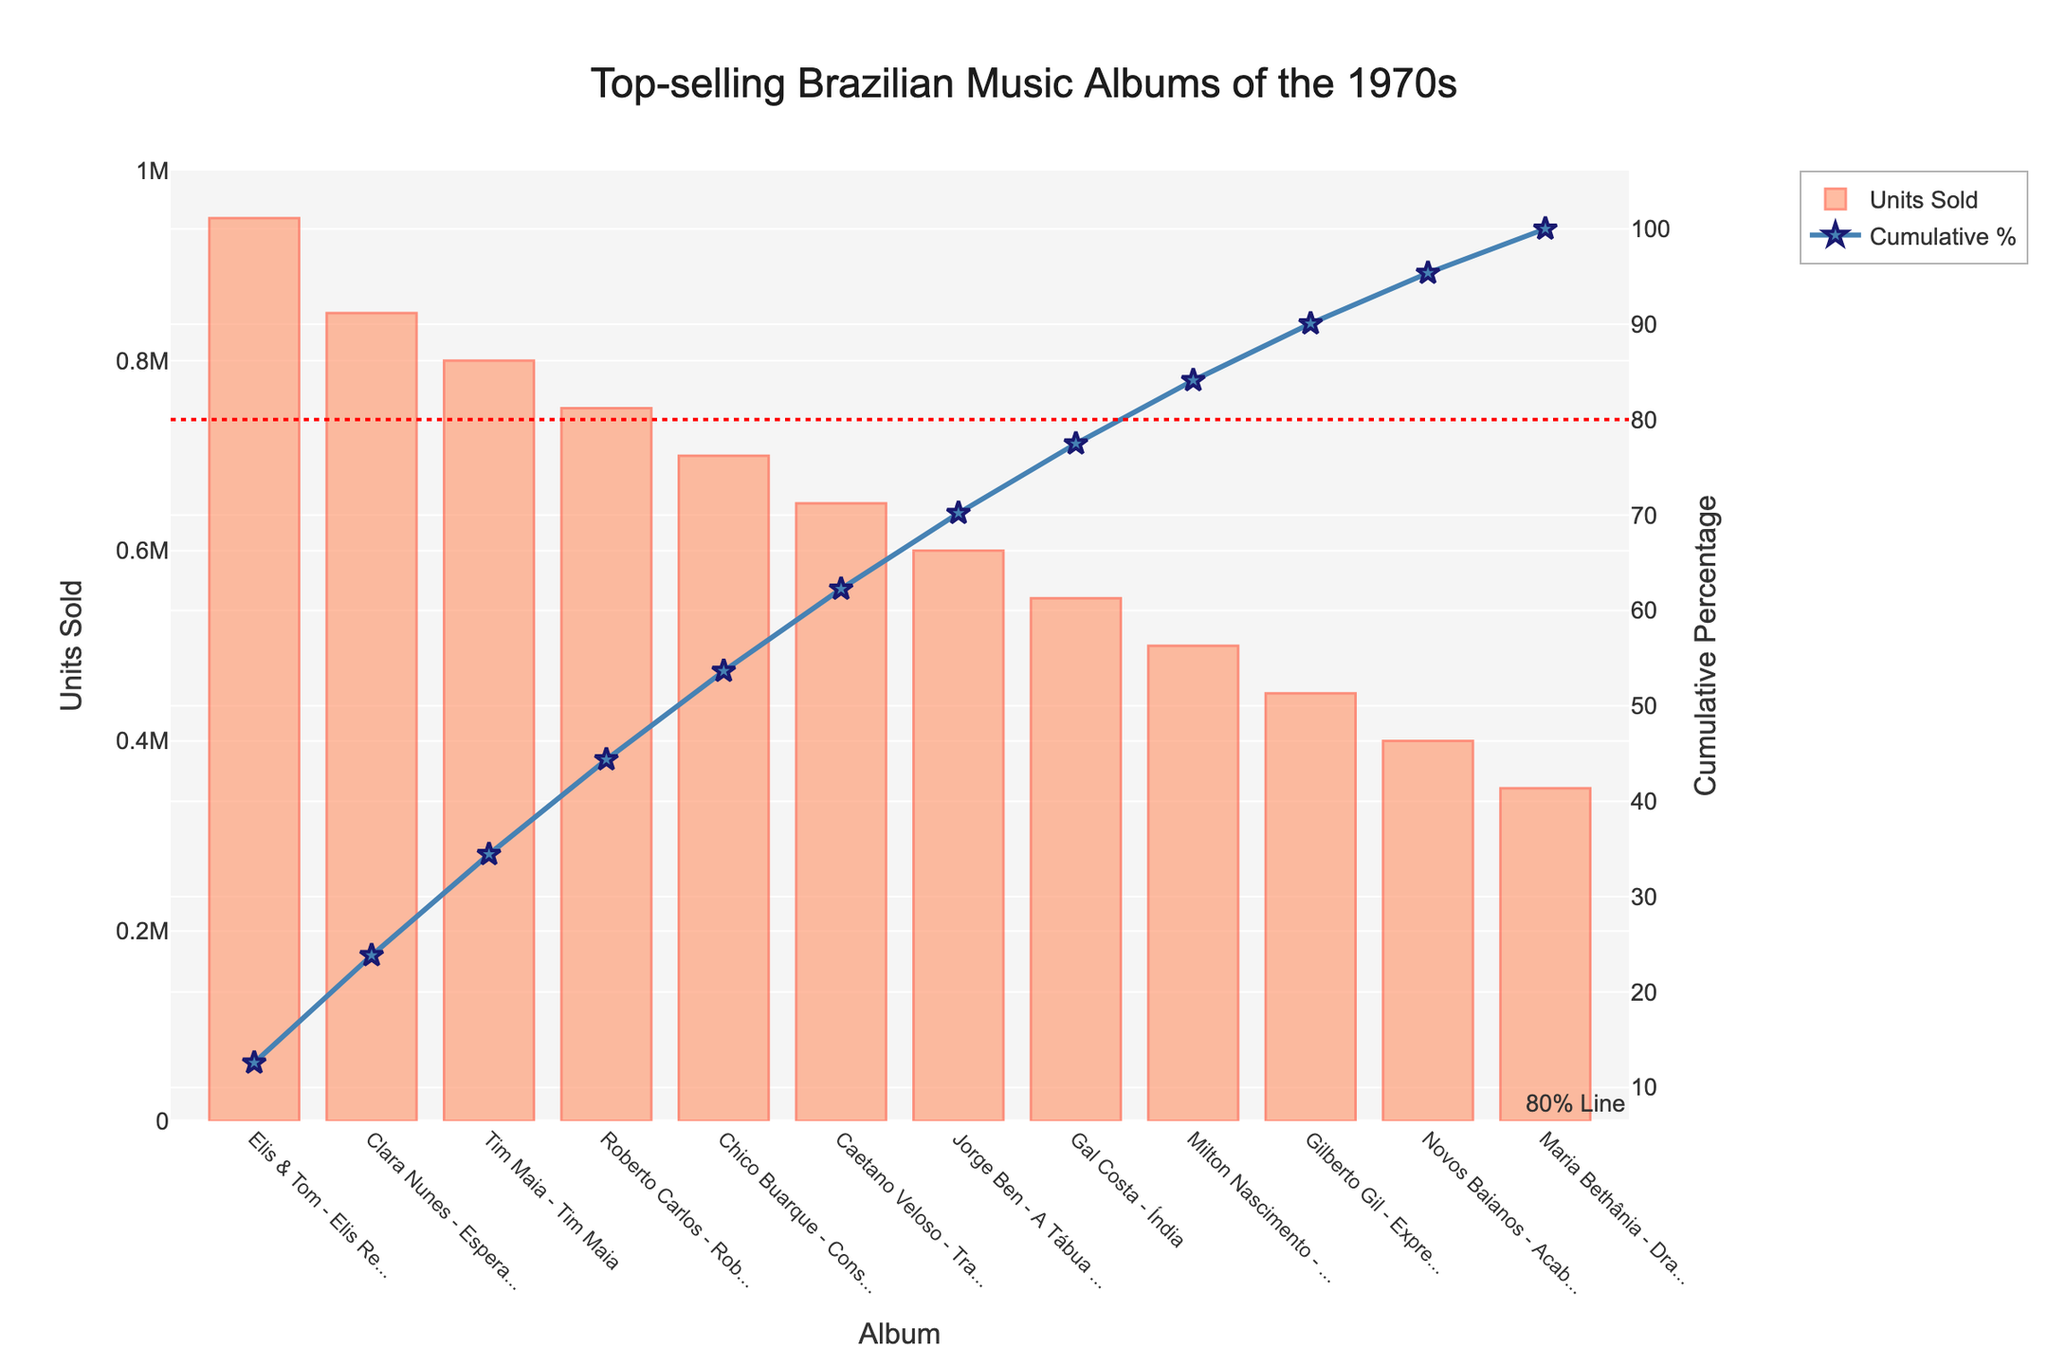What is the title of the chart? The title of the chart is usually located at the top and often gives a summary or main topic of the figure. Here, it is clearly mentioned at the top of the figure.
Answer: "Top-selling Brazilian Music Albums of the 1970s" What is the color of the bars representing units sold? By observing the bars, we can see how they are colored. The description mentions the bars are mainly #FFA07A.
Answer: Light salmon (light orange-red) Which album has sold the most units? Looking at the highest bar, we can identify the album with the most units sold.
Answer: "Elis & Tom - Elis Regina and Tom Jobim" What is the cumulative percentage after adding "Clara Nunes - Esperança"? We sum the units sold for the first two albums and check the cumulative percentage at this point, which is indicated by the scatter plot line.
Answer: 34.14% How many albums have sold at least 750,000 units? We identify the bars with units sold greater than or equal to 750,000 and count them.
Answer: 4 albums What is the cumulative percentage after the album "Roberto Carlos - Roberto Carlos"? Follow the cumulative percentage line till it reaches the point corresponding to "Roberto Carlos - Roberto Carlos".
Answer: 57.89% Which albums contribute to approximately 50% of total sales? We trace the cumulative percentage line to the 50% mark and observe which albums have been included up to that point.
Answer: Elis & Tom - Elis Regina and Tom Jobim, Clara Nunes - Esperança, Tim Maia - Tim Maia What is the difference in units sold between "Jorge Ben - A Tábua de Esmeralda" and "Milton Nascimento - Clube da Esquina"? Look at the units sold for both albums and subtract the smaller value from the larger value.
Answer: 100,000 What is the cumulative percentage contribution for "Caetano Veloso - Transa"? Check the cumulative percentage value at the album "Caetano Veloso - Transa" on the line plot.
Answer: 85.09% How many albums together account for at least 80% of total units sold? Trace the cumulative percentage line to 80% and count the number of albums up to that point.
Answer: 6 albums 